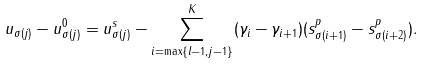Convert formula to latex. <formula><loc_0><loc_0><loc_500><loc_500>u _ { \sigma ( j ) } - u _ { \sigma ( j ) } ^ { 0 } = u _ { \sigma ( j ) } ^ { s } - \sum _ { i = \max \{ l - 1 , j - 1 \} } ^ { K } ( \gamma _ { i } - \gamma _ { i + 1 } ) ( s _ { \sigma ( i + 1 ) } ^ { p } - s _ { \sigma ( i + 2 ) } ^ { p } ) .</formula> 